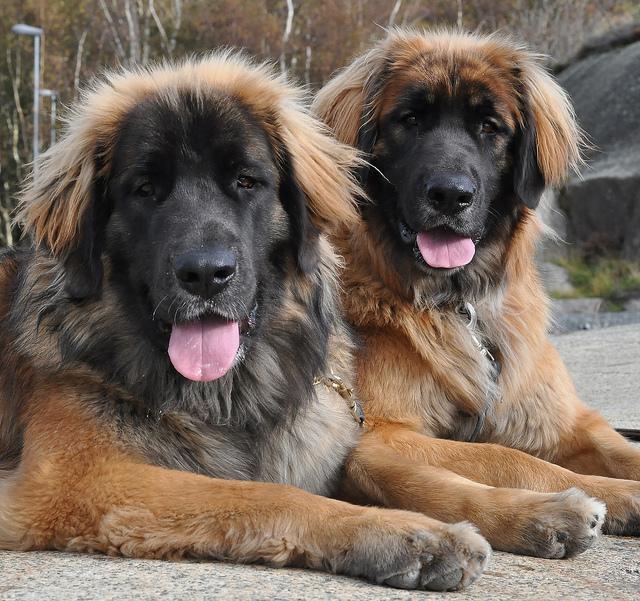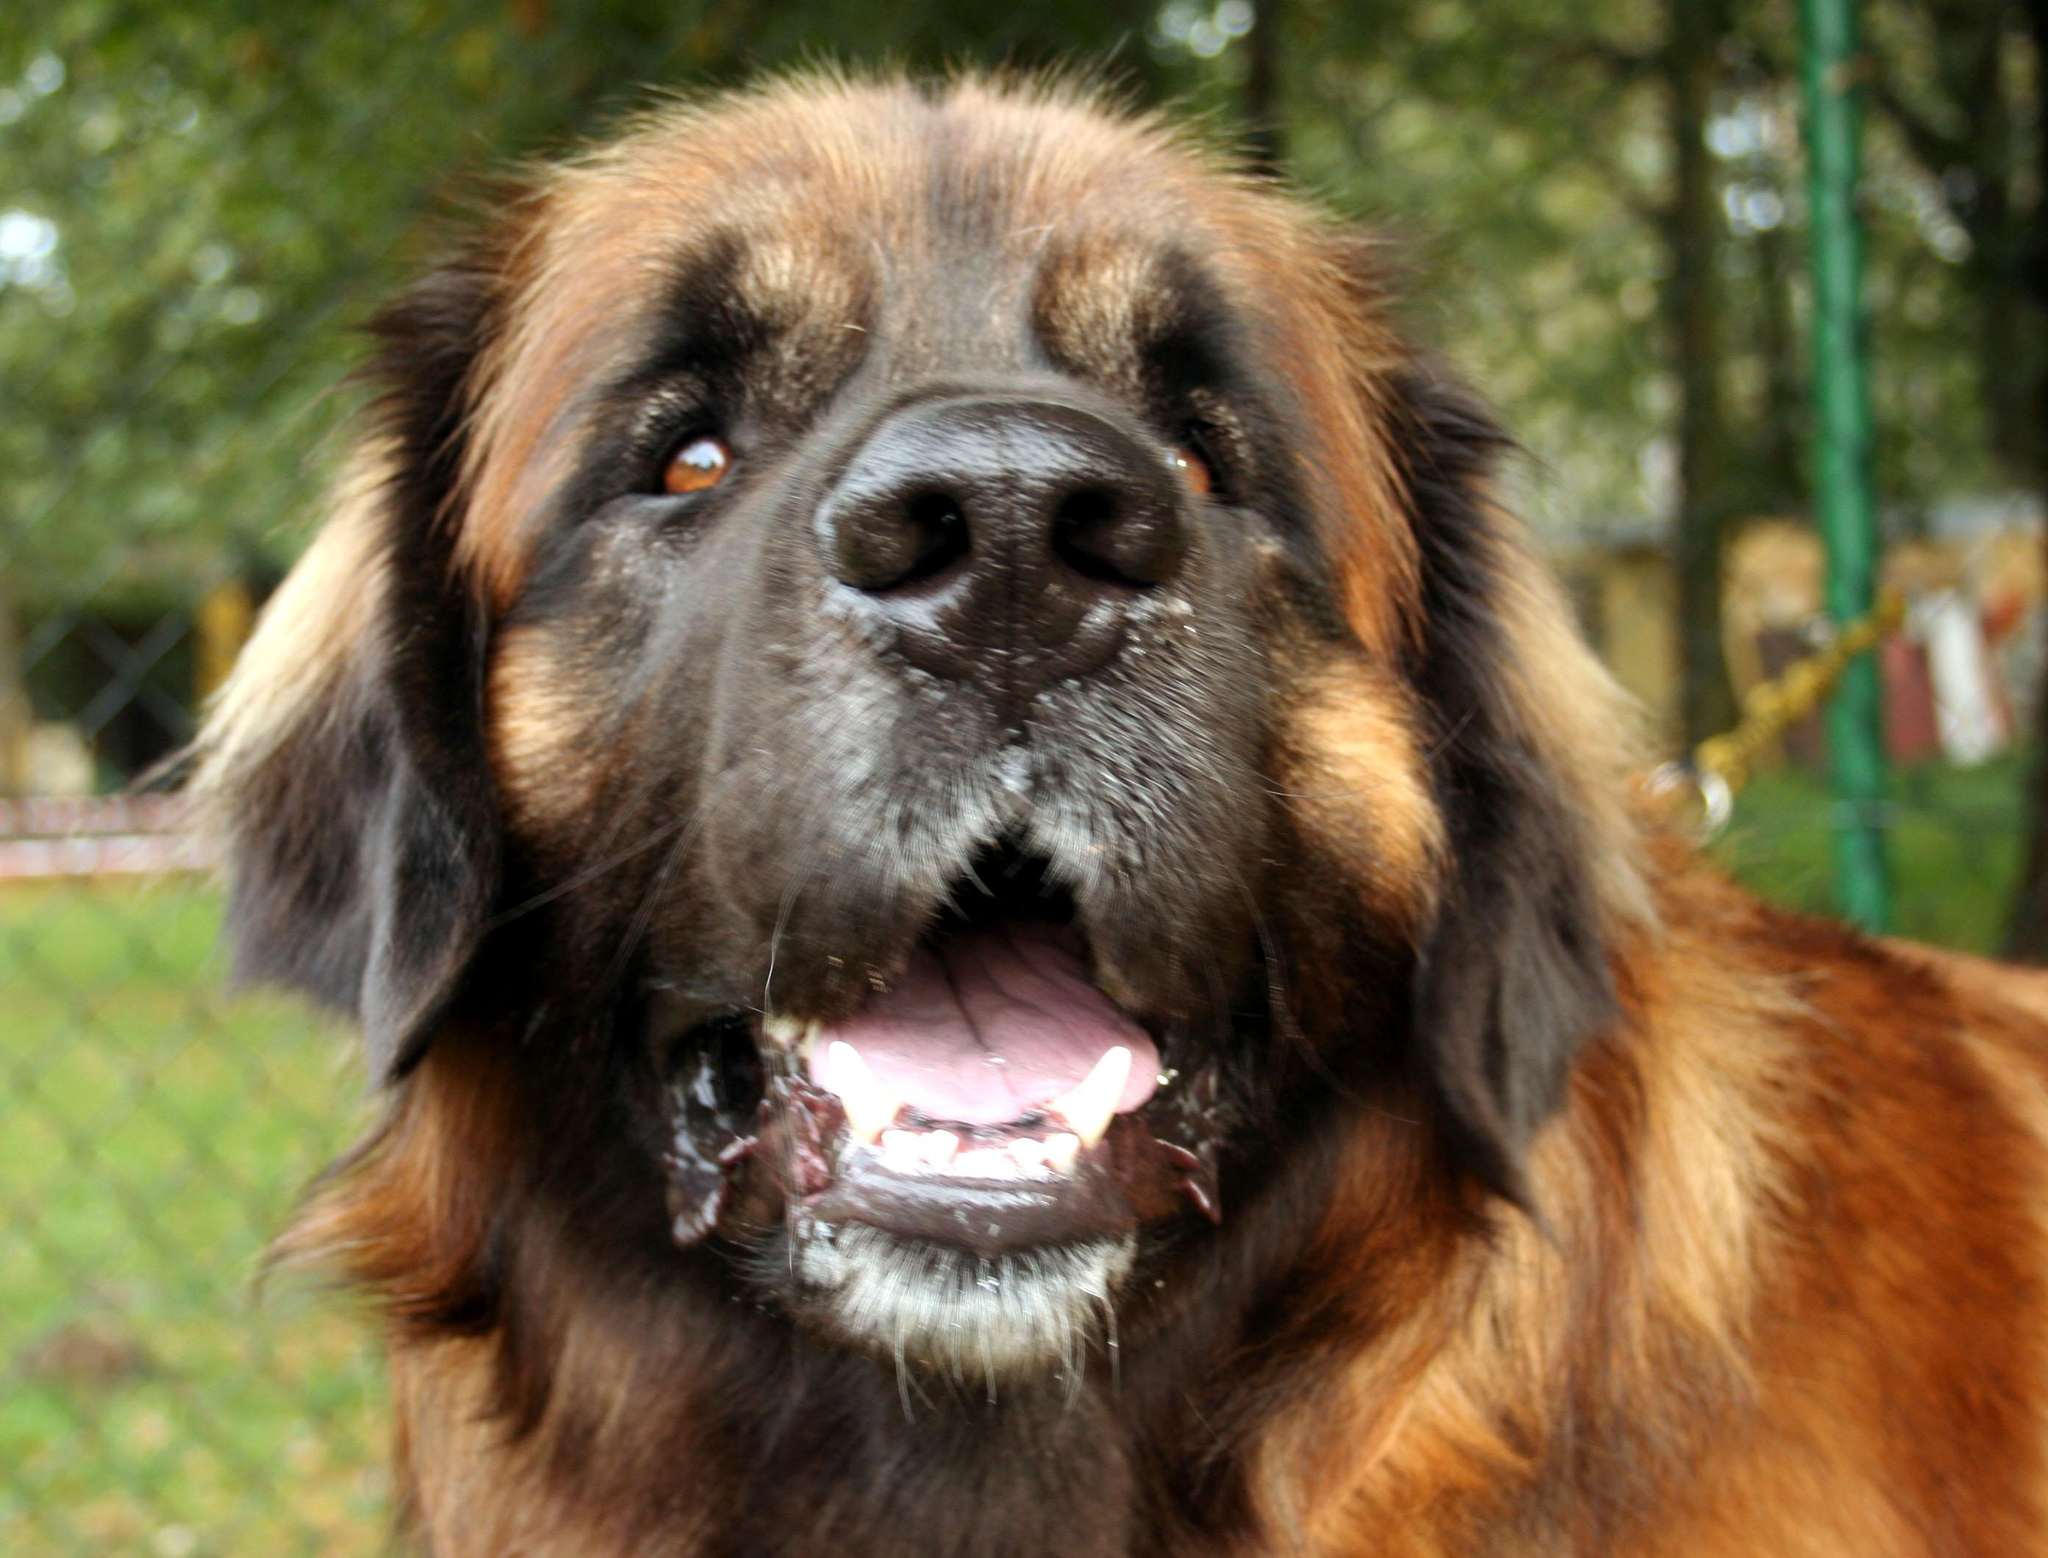The first image is the image on the left, the second image is the image on the right. Considering the images on both sides, is "There are three dogs in the pair of images." valid? Answer yes or no. Yes. The first image is the image on the left, the second image is the image on the right. Assess this claim about the two images: "A blue plastic plaything of some type is on the grass in one of the images featuring a big brownish-orange dog.". Correct or not? Answer yes or no. No. 